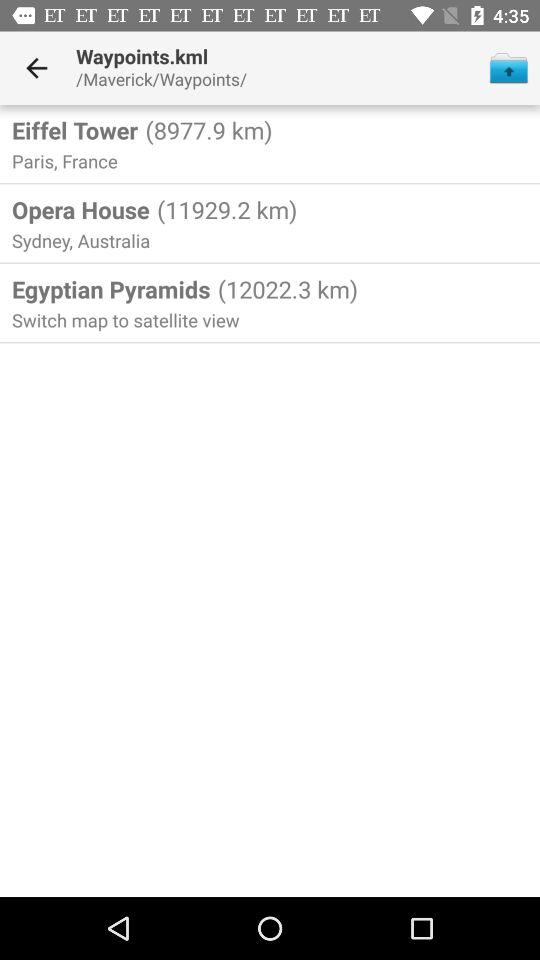How far is the "Opera House"? The "Opera House" is 11929.2 km away. 